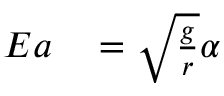Convert formula to latex. <formula><loc_0><loc_0><loc_500><loc_500>\begin{array} { r l } { E a } & = \sqrt { \frac { g } { r } } \alpha } \end{array}</formula> 